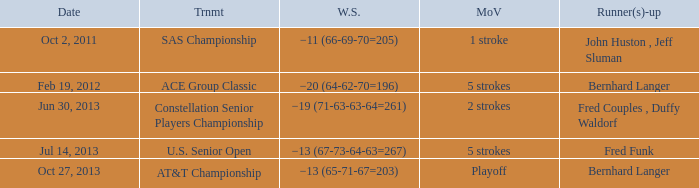What winning margin is present in a u.s. senior open tournament? 5 strokes. 